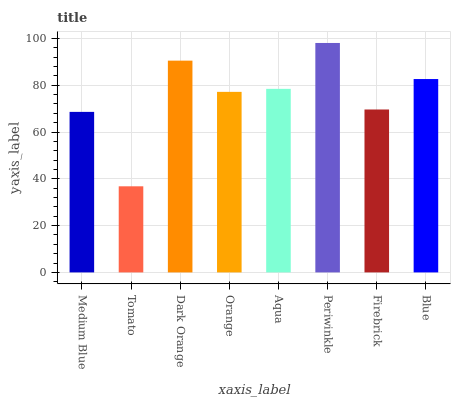Is Tomato the minimum?
Answer yes or no. Yes. Is Periwinkle the maximum?
Answer yes or no. Yes. Is Dark Orange the minimum?
Answer yes or no. No. Is Dark Orange the maximum?
Answer yes or no. No. Is Dark Orange greater than Tomato?
Answer yes or no. Yes. Is Tomato less than Dark Orange?
Answer yes or no. Yes. Is Tomato greater than Dark Orange?
Answer yes or no. No. Is Dark Orange less than Tomato?
Answer yes or no. No. Is Aqua the high median?
Answer yes or no. Yes. Is Orange the low median?
Answer yes or no. Yes. Is Periwinkle the high median?
Answer yes or no. No. Is Tomato the low median?
Answer yes or no. No. 